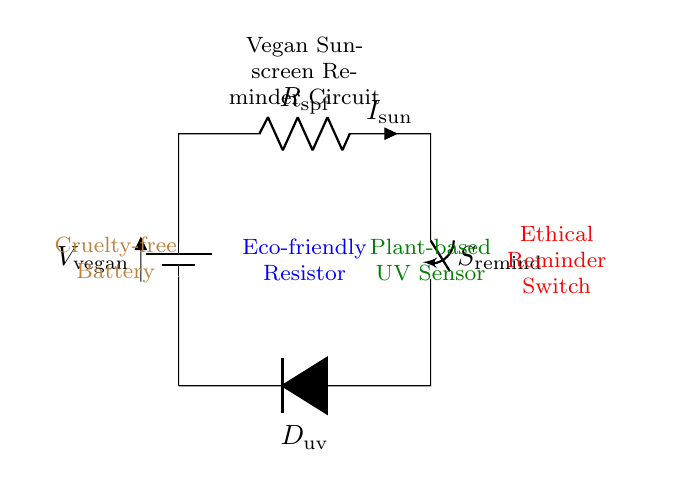What is the voltage source in this circuit? The voltage source in the circuit is labeled as V_vegan, indicating it powers a vegan-related application.
Answer: V_vegan What type of resistor is used in this circuit? The resistor is labeled as R_spf, which suggests it is specifically related to protecting against sun exposure (sun protection factor).
Answer: Eco-friendly Resistor What component acts as a reminder switch in the circuit? The circuit diagram labels a switch as S_remind, designed to activate the reminder function for sunscreen application.
Answer: Ethical Reminder Switch How many main components are in this circuit? The circuit consists of a battery, resistor, switch, and diode, totaling four main components.
Answer: Four What does the diode in the circuit signify? The diode is labeled as D_uv, indicating it detects UV light, crucial for activating the reminder due to sun exposure.
Answer: Plant-based UV Sensor How does the switch interact with the current flow? The switch, when closed, allows current to flow through the circuit, connecting the various components to function together.
Answer: Allows Current Flow What ethical principle does the battery represent? The battery is described as a cruelty-free battery, representing a commitment to ethical treatment and non-exploitation of animals.
Answer: Cruelty-free Battery 